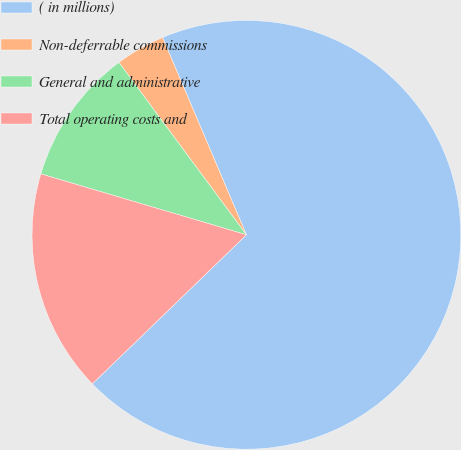<chart> <loc_0><loc_0><loc_500><loc_500><pie_chart><fcel>( in millions)<fcel>Non-deferrable commissions<fcel>General and administrative<fcel>Total operating costs and<nl><fcel>69.16%<fcel>3.74%<fcel>10.28%<fcel>16.82%<nl></chart> 